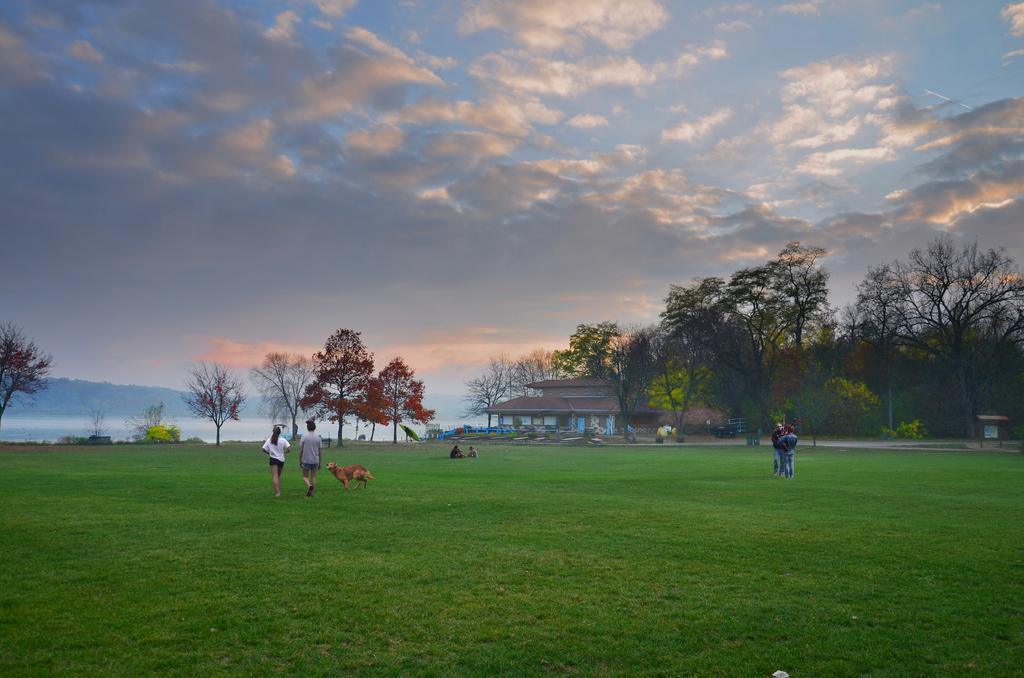Could you give a brief overview of what you see in this image? In the image in the center, we can see a few people and one dog, which is in brown color. In the background, we can see the sky, clouds, trees, plants, grass, one building, poles, one outdoor umbrella and a few other objects. 